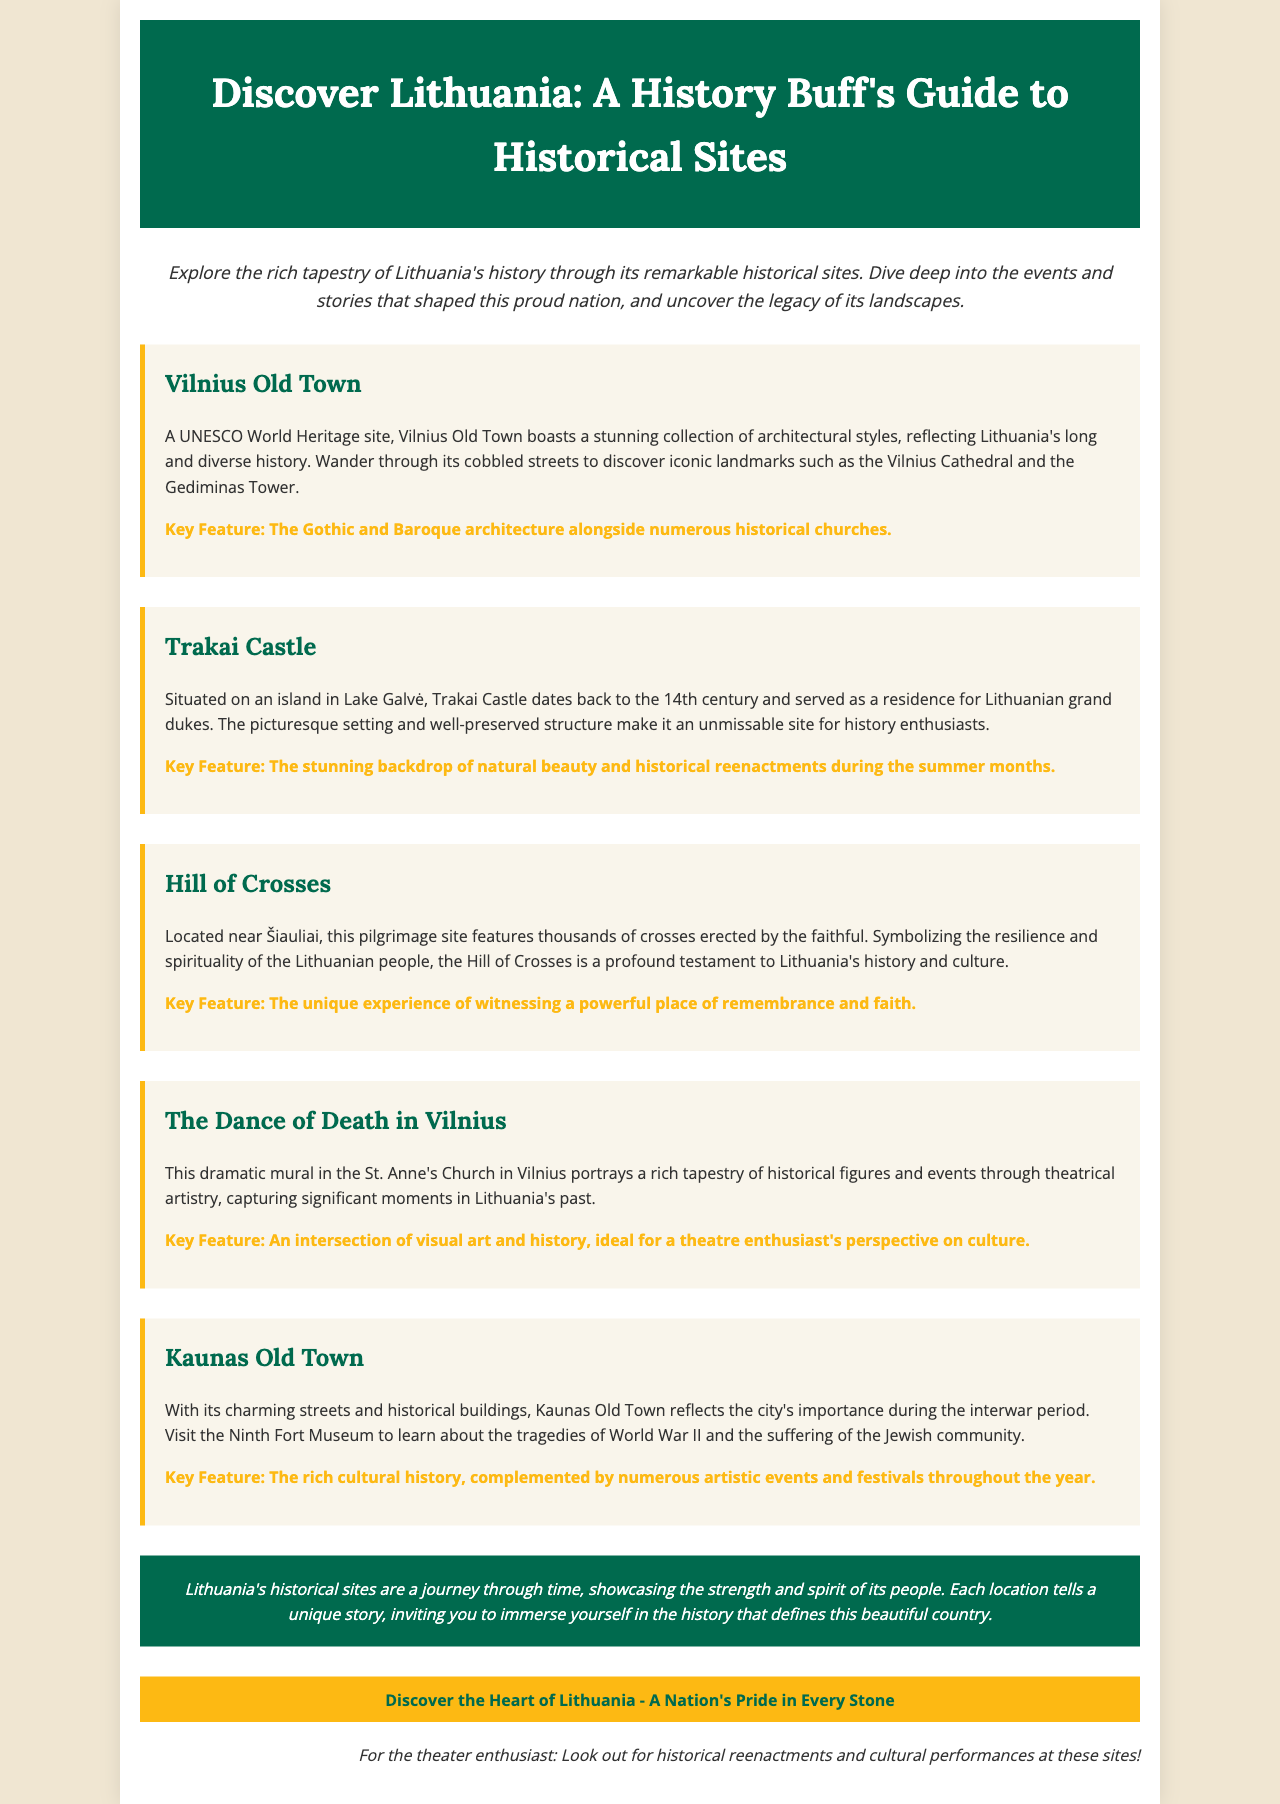What is a UNESCO World Heritage site mentioned in the brochure? The brochure highlights Vilnius Old Town as a UNESCO World Heritage site, emphasizing its architectural beauty and historical significance.
Answer: Vilnius Old Town What century does Trakai Castle date back to? The document specifies that Trakai Castle dates back to the 14th century, indicating its long history as a residence for Lithuanian grand dukes.
Answer: 14th century What key feature is associated with the Hill of Crosses? The brochure describes the Hill of Crosses as a unique experience that symbolizes resilience and spirituality, showcasing a significant aspect of Lithuanian culture.
Answer: A powerful place of remembrance and faith Which mural is located in St. Anne's Church? The document mentions "The Dance of Death" as the mural that portrays historical figures and events, emphasizing its cultural importance.
Answer: The Dance of Death Which city is highlighted for its interwar period significance? Kaunas Old Town is mentioned for its charming streets and historical relevance during the interwar period, along with its memorials to WWII tragedies.
Answer: Kaunas Old Town What does the brochure suggest looking out for at historical sites? The document notes that theater enthusiasts should look for historical reenactments and cultural performances at various historical sites.
Answer: Historical reenactments and cultural performances 